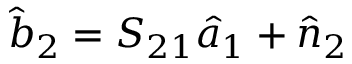Convert formula to latex. <formula><loc_0><loc_0><loc_500><loc_500>\hat { b } _ { 2 } = S _ { 2 1 } \hat { a } _ { 1 } + \hat { n } _ { 2 }</formula> 